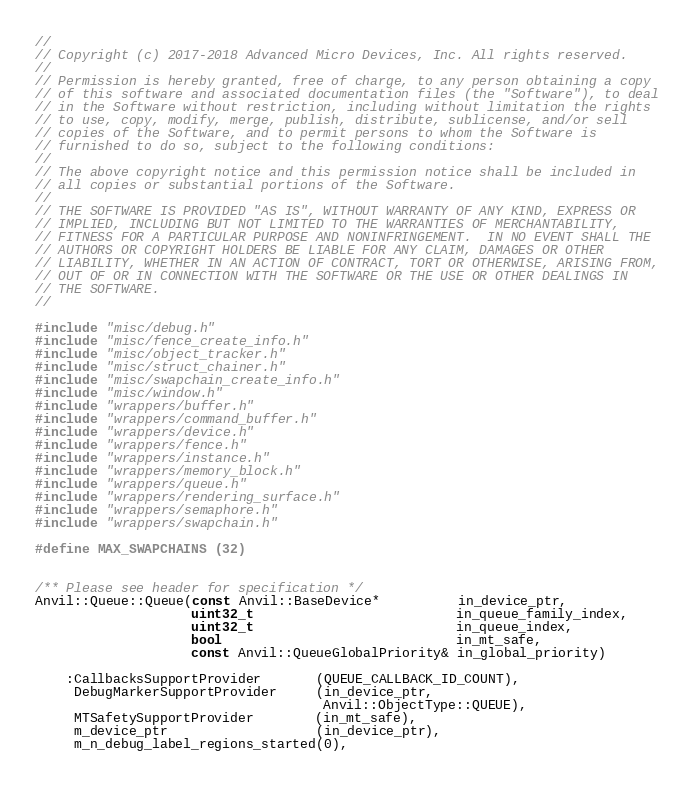Convert code to text. <code><loc_0><loc_0><loc_500><loc_500><_C++_>//
// Copyright (c) 2017-2018 Advanced Micro Devices, Inc. All rights reserved.
//
// Permission is hereby granted, free of charge, to any person obtaining a copy
// of this software and associated documentation files (the "Software"), to deal
// in the Software without restriction, including without limitation the rights
// to use, copy, modify, merge, publish, distribute, sublicense, and/or sell
// copies of the Software, and to permit persons to whom the Software is
// furnished to do so, subject to the following conditions:
//
// The above copyright notice and this permission notice shall be included in
// all copies or substantial portions of the Software.
//
// THE SOFTWARE IS PROVIDED "AS IS", WITHOUT WARRANTY OF ANY KIND, EXPRESS OR
// IMPLIED, INCLUDING BUT NOT LIMITED TO THE WARRANTIES OF MERCHANTABILITY,
// FITNESS FOR A PARTICULAR PURPOSE AND NONINFRINGEMENT.  IN NO EVENT SHALL THE
// AUTHORS OR COPYRIGHT HOLDERS BE LIABLE FOR ANY CLAIM, DAMAGES OR OTHER
// LIABILITY, WHETHER IN AN ACTION OF CONTRACT, TORT OR OTHERWISE, ARISING FROM,
// OUT OF OR IN CONNECTION WITH THE SOFTWARE OR THE USE OR OTHER DEALINGS IN
// THE SOFTWARE.
//

#include "misc/debug.h"
#include "misc/fence_create_info.h"
#include "misc/object_tracker.h"
#include "misc/struct_chainer.h"
#include "misc/swapchain_create_info.h"
#include "misc/window.h"
#include "wrappers/buffer.h"
#include "wrappers/command_buffer.h"
#include "wrappers/device.h"
#include "wrappers/fence.h"
#include "wrappers/instance.h"
#include "wrappers/memory_block.h"
#include "wrappers/queue.h"
#include "wrappers/rendering_surface.h"
#include "wrappers/semaphore.h"
#include "wrappers/swapchain.h"

#define MAX_SWAPCHAINS (32)


/** Please see header for specification */
Anvil::Queue::Queue(const Anvil::BaseDevice*          in_device_ptr,
                    uint32_t                          in_queue_family_index,
                    uint32_t                          in_queue_index,
                    bool                              in_mt_safe,
                    const Anvil::QueueGlobalPriority& in_global_priority)

    :CallbacksSupportProvider       (QUEUE_CALLBACK_ID_COUNT),
     DebugMarkerSupportProvider     (in_device_ptr,
                                     Anvil::ObjectType::QUEUE),
     MTSafetySupportProvider        (in_mt_safe),
     m_device_ptr                   (in_device_ptr),
     m_n_debug_label_regions_started(0),</code> 